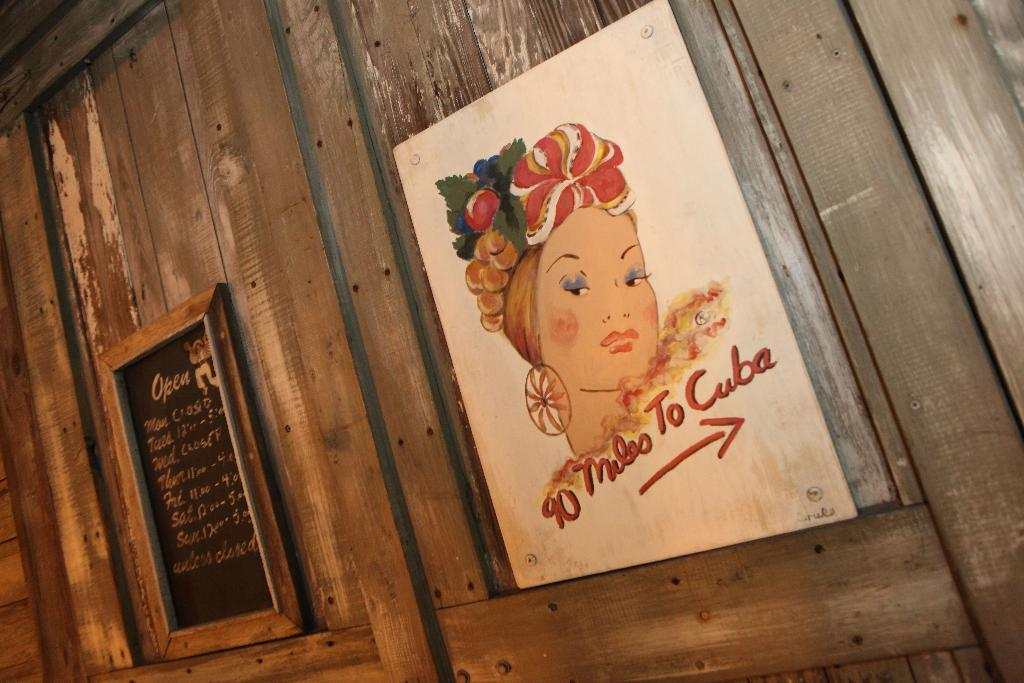<image>
Write a terse but informative summary of the picture. picture of womans head on wall that states 10 miles to Cuba 